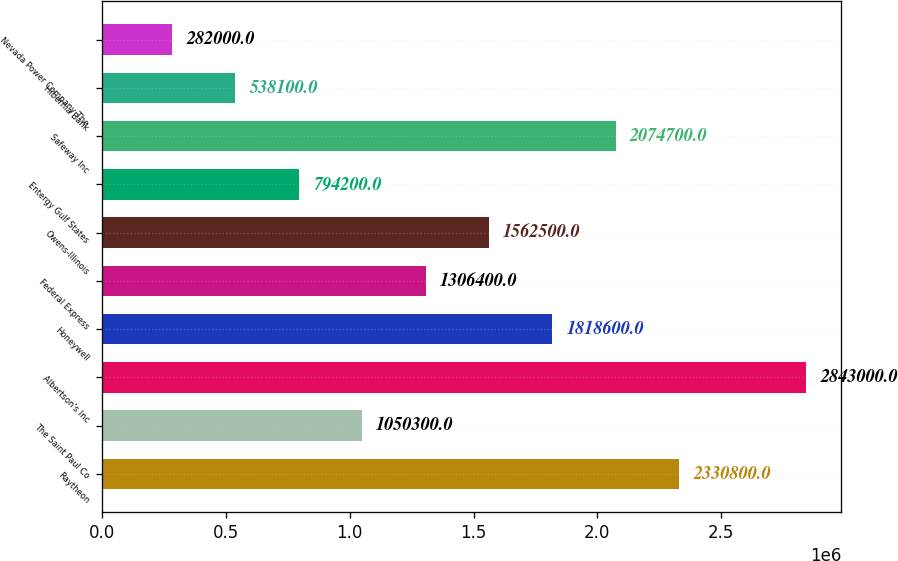<chart> <loc_0><loc_0><loc_500><loc_500><bar_chart><fcel>Raytheon<fcel>The Saint Paul Co<fcel>Albertson's Inc<fcel>Honeywell<fcel>Federal Express<fcel>Owens-Illinois<fcel>Entergy Gulf States<fcel>Safeway Inc<fcel>Hibernia Bank<fcel>Nevada Power Company The<nl><fcel>2.3308e+06<fcel>1.0503e+06<fcel>2.843e+06<fcel>1.8186e+06<fcel>1.3064e+06<fcel>1.5625e+06<fcel>794200<fcel>2.0747e+06<fcel>538100<fcel>282000<nl></chart> 